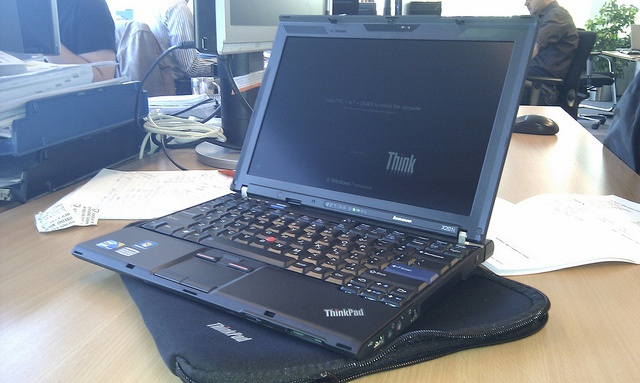Describe the objects in this image and their specific colors. I can see laptop in darkgray, darkblue, navy, and gray tones, people in gray and darkgray tones, people in darkgray, gray, and lightblue tones, book in gray, lightblue, and lightgray tones, and chair in gray, darkgray, and lightblue tones in this image. 